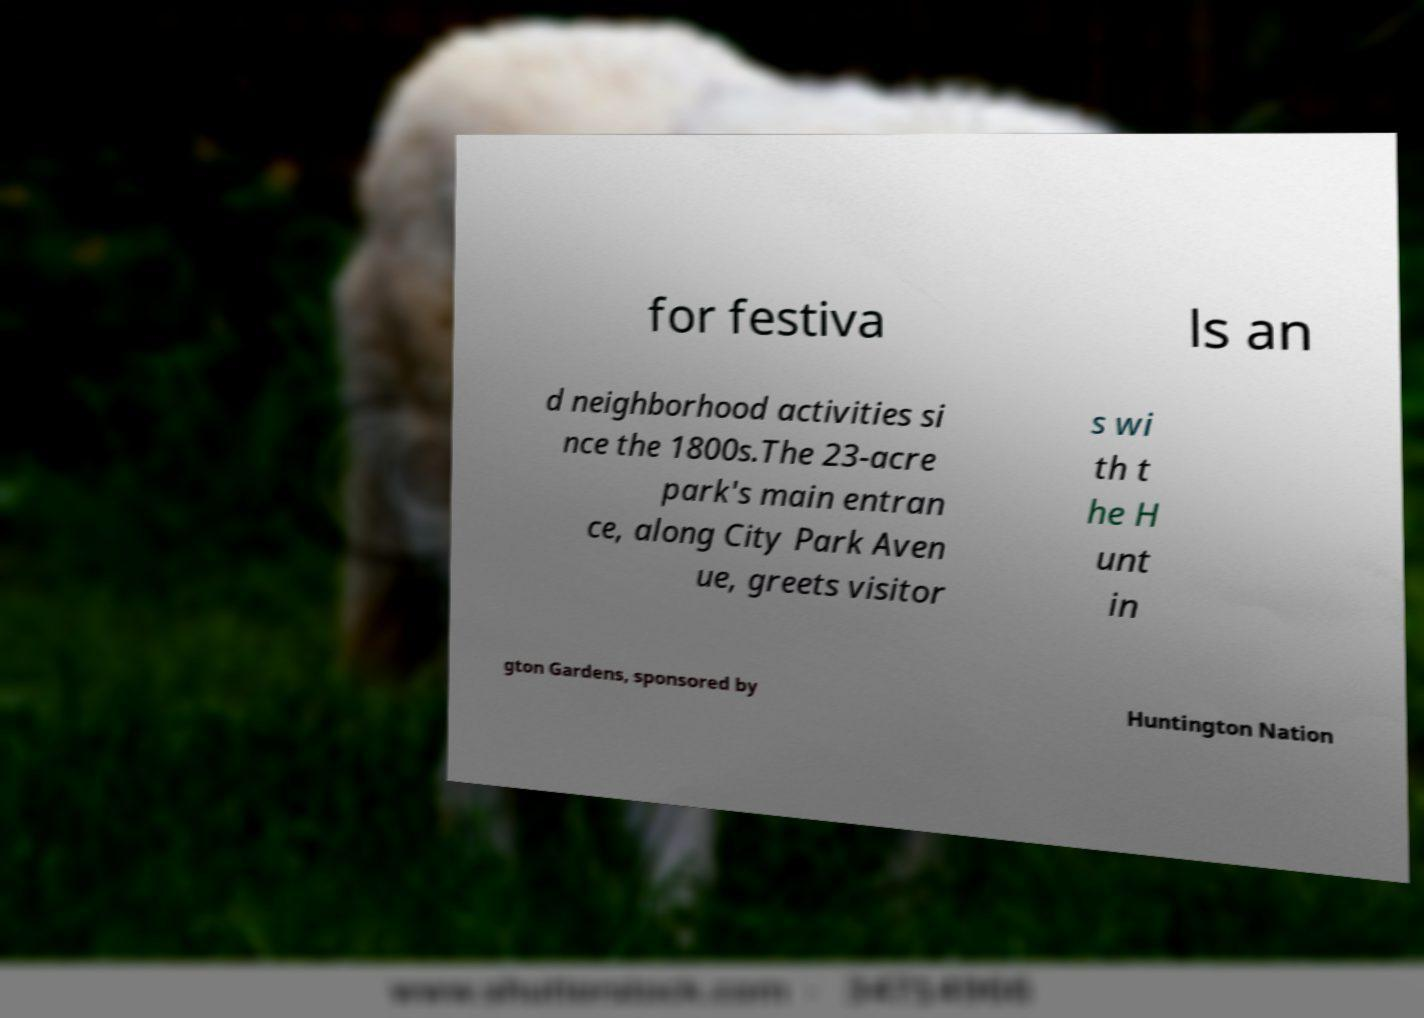What messages or text are displayed in this image? I need them in a readable, typed format. for festiva ls an d neighborhood activities si nce the 1800s.The 23-acre park's main entran ce, along City Park Aven ue, greets visitor s wi th t he H unt in gton Gardens, sponsored by Huntington Nation 